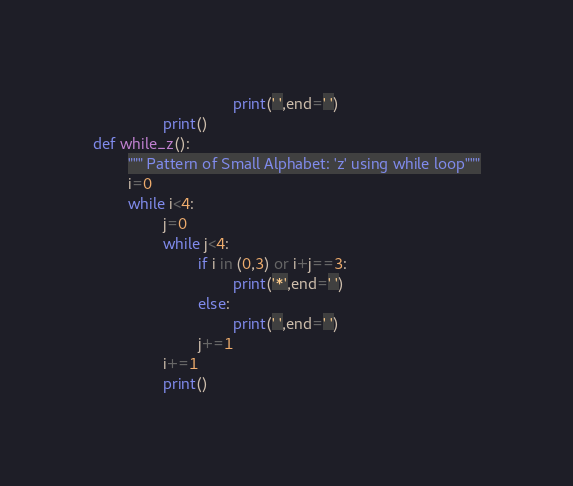<code> <loc_0><loc_0><loc_500><loc_500><_Python_>                                print(' ',end=' ')
                print()
def while_z():
        """ Pattern of Small Alphabet: 'z' using while loop"""
        i=0
        while i<4:
                j=0
                while j<4:
                        if i in (0,3) or i+j==3:
                                print('*',end=' ')
                        else:
                                print(' ',end=' ')
                        j+=1
                i+=1
                print()
</code> 